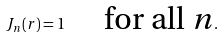Convert formula to latex. <formula><loc_0><loc_0><loc_500><loc_500>J _ { n } ( r ) = 1 \quad \text { for all $n$} .</formula> 